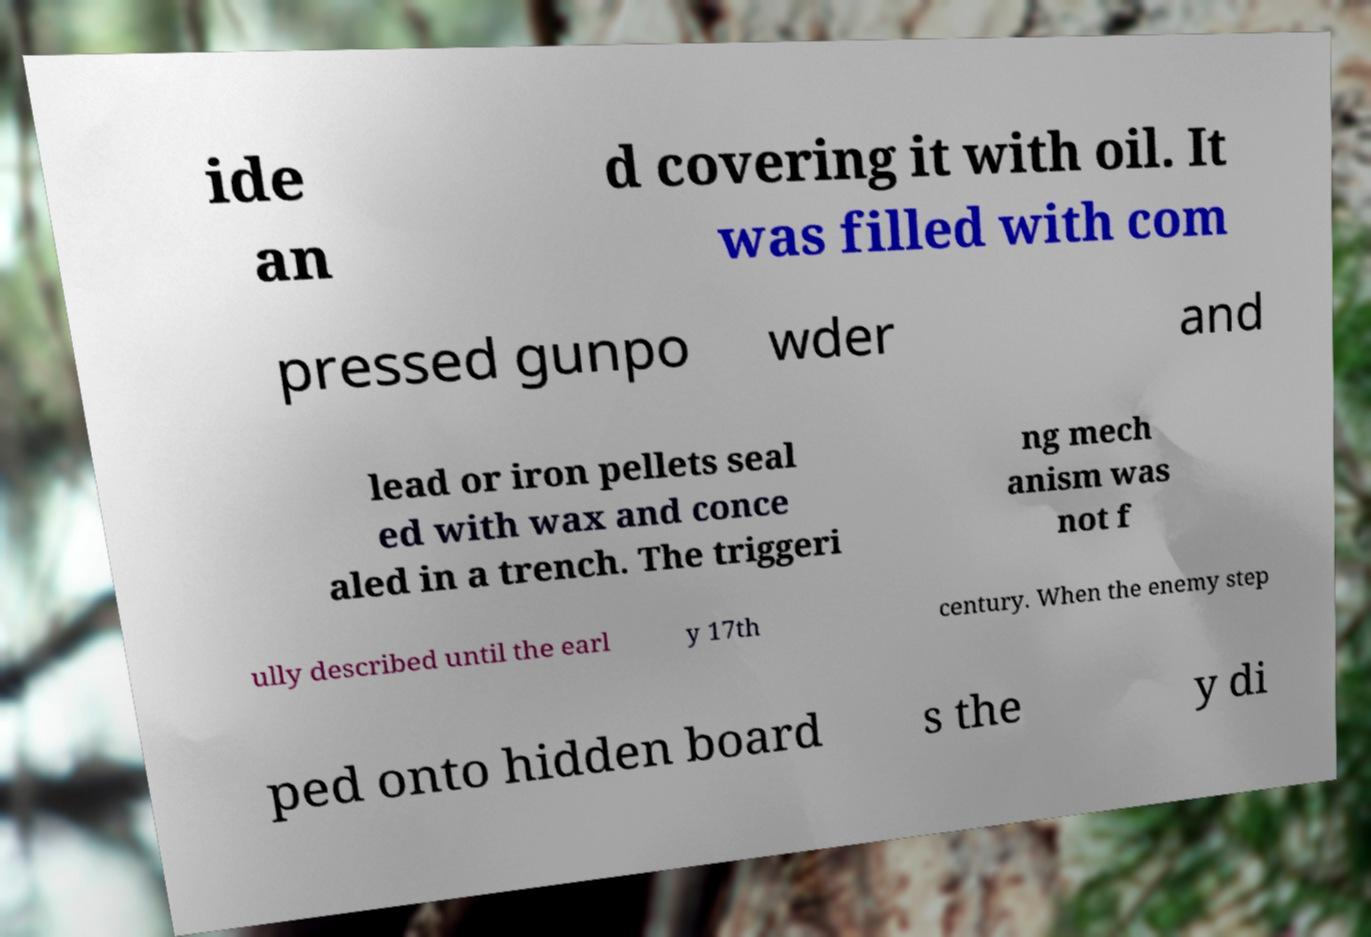For documentation purposes, I need the text within this image transcribed. Could you provide that? ide an d covering it with oil. It was filled with com pressed gunpo wder and lead or iron pellets seal ed with wax and conce aled in a trench. The triggeri ng mech anism was not f ully described until the earl y 17th century. When the enemy step ped onto hidden board s the y di 